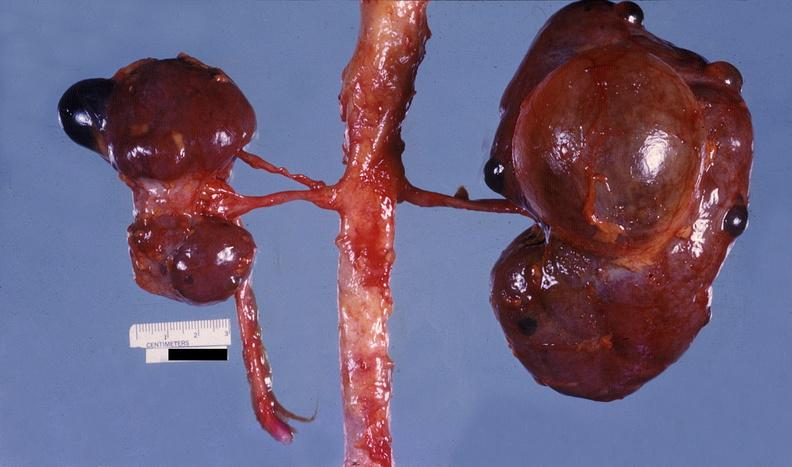what does this image show?
Answer the question using a single word or phrase. Kidney 